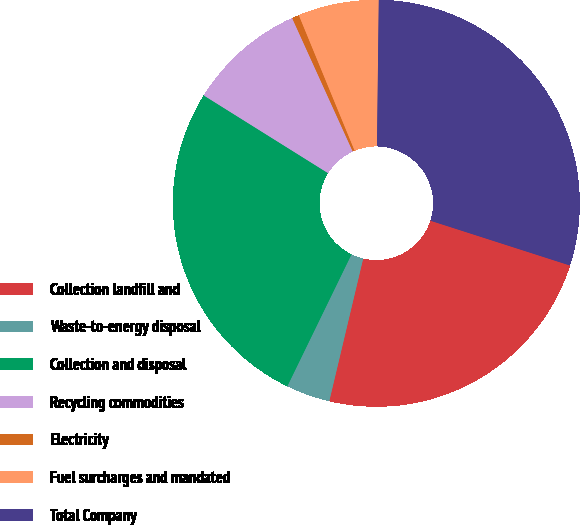Convert chart to OTSL. <chart><loc_0><loc_0><loc_500><loc_500><pie_chart><fcel>Collection landfill and<fcel>Waste-to-energy disposal<fcel>Collection and disposal<fcel>Recycling commodities<fcel>Electricity<fcel>Fuel surcharges and mandated<fcel>Total Company<nl><fcel>23.77%<fcel>3.49%<fcel>26.69%<fcel>9.32%<fcel>0.57%<fcel>6.41%<fcel>29.75%<nl></chart> 